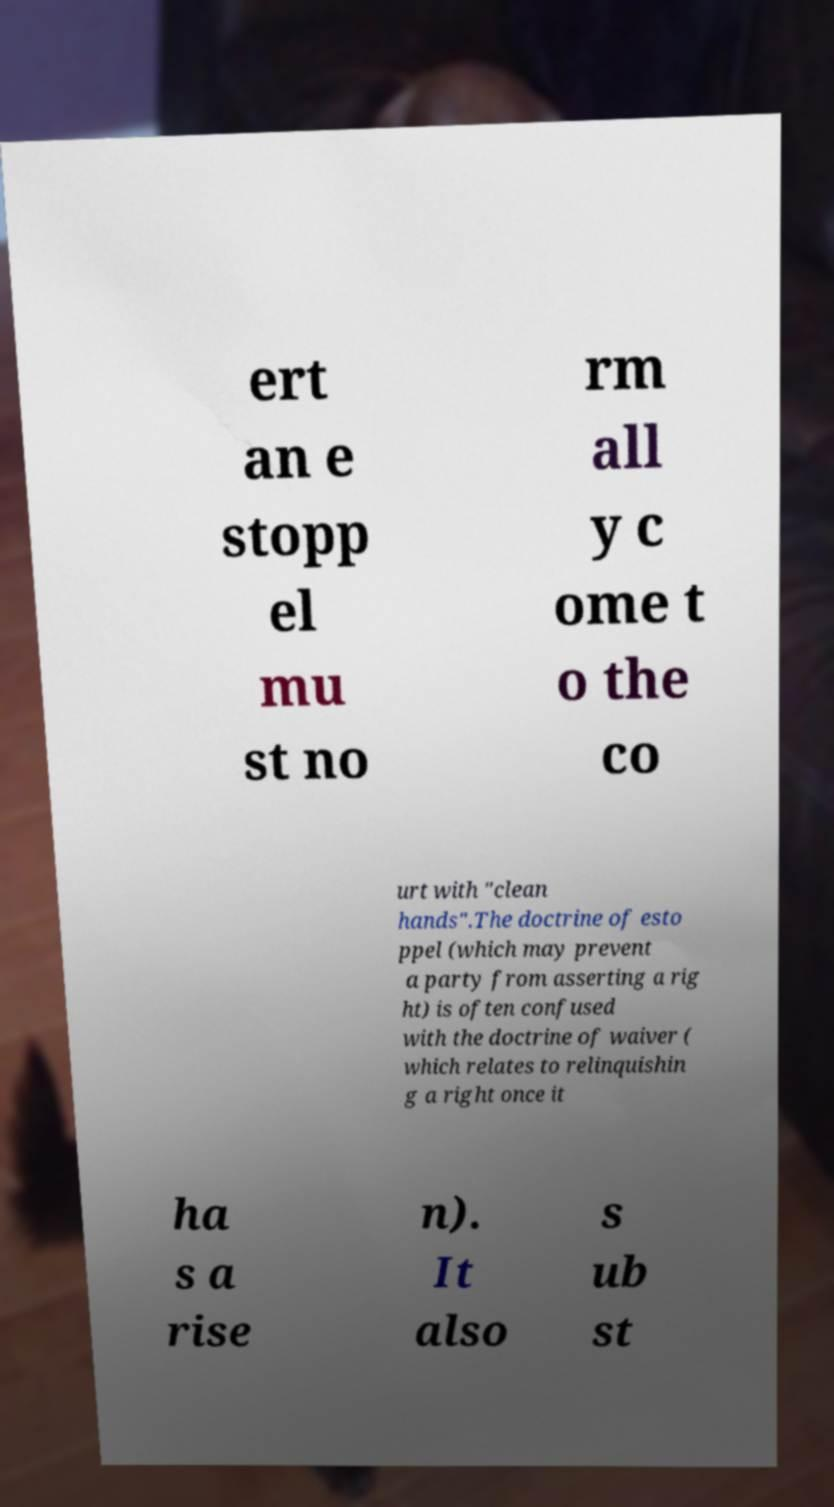What messages or text are displayed in this image? I need them in a readable, typed format. ert an e stopp el mu st no rm all y c ome t o the co urt with "clean hands".The doctrine of esto ppel (which may prevent a party from asserting a rig ht) is often confused with the doctrine of waiver ( which relates to relinquishin g a right once it ha s a rise n). It also s ub st 